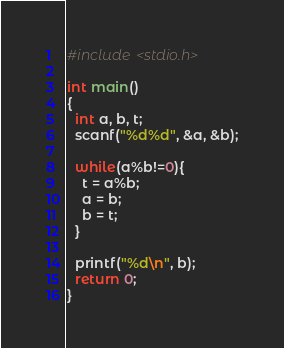Convert code to text. <code><loc_0><loc_0><loc_500><loc_500><_C_>#include <stdio.h>
 
int main()
{
  int a, b, t;
  scanf("%d%d", &a, &b);
 
  while(a%b!=0){
    t = a%b;
    a = b;
    b = t;
  }
 
  printf("%d\n", b);
  return 0;
}</code> 